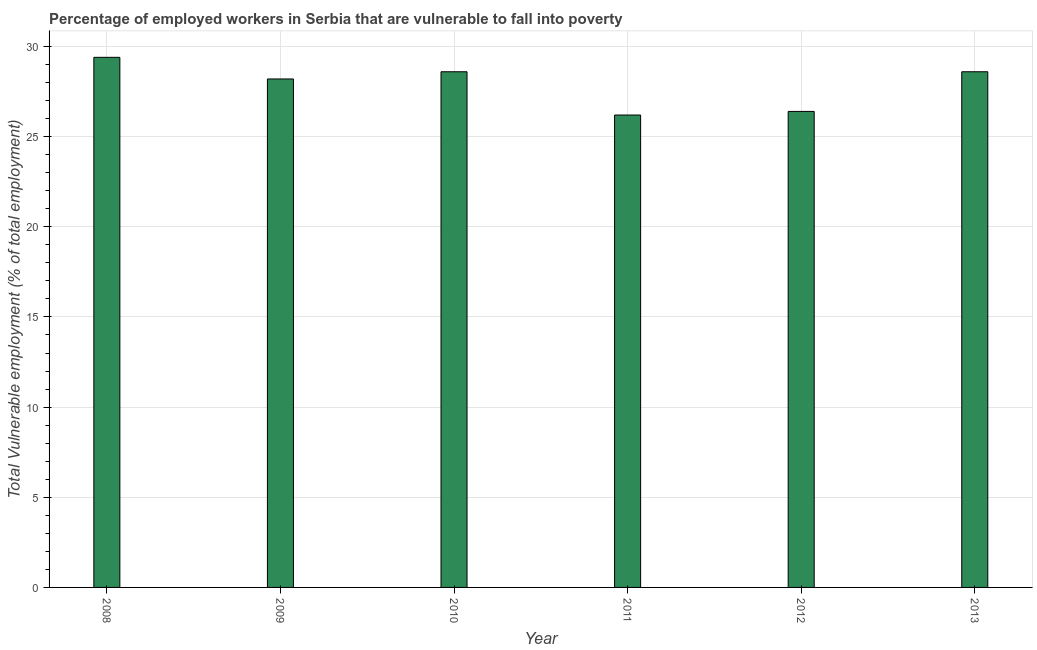Does the graph contain any zero values?
Offer a terse response. No. What is the title of the graph?
Your answer should be compact. Percentage of employed workers in Serbia that are vulnerable to fall into poverty. What is the label or title of the Y-axis?
Offer a terse response. Total Vulnerable employment (% of total employment). What is the total vulnerable employment in 2012?
Make the answer very short. 26.4. Across all years, what is the maximum total vulnerable employment?
Provide a succinct answer. 29.4. Across all years, what is the minimum total vulnerable employment?
Your answer should be very brief. 26.2. In which year was the total vulnerable employment maximum?
Offer a terse response. 2008. What is the sum of the total vulnerable employment?
Ensure brevity in your answer.  167.4. What is the average total vulnerable employment per year?
Keep it short and to the point. 27.9. What is the median total vulnerable employment?
Ensure brevity in your answer.  28.4. In how many years, is the total vulnerable employment greater than 6 %?
Keep it short and to the point. 6. What is the ratio of the total vulnerable employment in 2009 to that in 2012?
Your response must be concise. 1.07. Is the total vulnerable employment in 2011 less than that in 2013?
Your response must be concise. Yes. Is the sum of the total vulnerable employment in 2010 and 2011 greater than the maximum total vulnerable employment across all years?
Keep it short and to the point. Yes. In how many years, is the total vulnerable employment greater than the average total vulnerable employment taken over all years?
Offer a very short reply. 4. Are all the bars in the graph horizontal?
Offer a terse response. No. What is the Total Vulnerable employment (% of total employment) in 2008?
Give a very brief answer. 29.4. What is the Total Vulnerable employment (% of total employment) in 2009?
Give a very brief answer. 28.2. What is the Total Vulnerable employment (% of total employment) of 2010?
Give a very brief answer. 28.6. What is the Total Vulnerable employment (% of total employment) of 2011?
Your answer should be compact. 26.2. What is the Total Vulnerable employment (% of total employment) of 2012?
Offer a very short reply. 26.4. What is the Total Vulnerable employment (% of total employment) in 2013?
Your answer should be compact. 28.6. What is the difference between the Total Vulnerable employment (% of total employment) in 2008 and 2009?
Provide a succinct answer. 1.2. What is the difference between the Total Vulnerable employment (% of total employment) in 2008 and 2010?
Keep it short and to the point. 0.8. What is the difference between the Total Vulnerable employment (% of total employment) in 2008 and 2011?
Keep it short and to the point. 3.2. What is the difference between the Total Vulnerable employment (% of total employment) in 2008 and 2012?
Your answer should be very brief. 3. What is the difference between the Total Vulnerable employment (% of total employment) in 2009 and 2010?
Your answer should be very brief. -0.4. What is the difference between the Total Vulnerable employment (% of total employment) in 2009 and 2011?
Your answer should be very brief. 2. What is the difference between the Total Vulnerable employment (% of total employment) in 2009 and 2012?
Make the answer very short. 1.8. What is the difference between the Total Vulnerable employment (% of total employment) in 2009 and 2013?
Your response must be concise. -0.4. What is the difference between the Total Vulnerable employment (% of total employment) in 2010 and 2011?
Provide a succinct answer. 2.4. What is the difference between the Total Vulnerable employment (% of total employment) in 2010 and 2013?
Provide a succinct answer. 0. What is the difference between the Total Vulnerable employment (% of total employment) in 2012 and 2013?
Keep it short and to the point. -2.2. What is the ratio of the Total Vulnerable employment (% of total employment) in 2008 to that in 2009?
Your answer should be compact. 1.04. What is the ratio of the Total Vulnerable employment (% of total employment) in 2008 to that in 2010?
Keep it short and to the point. 1.03. What is the ratio of the Total Vulnerable employment (% of total employment) in 2008 to that in 2011?
Keep it short and to the point. 1.12. What is the ratio of the Total Vulnerable employment (% of total employment) in 2008 to that in 2012?
Make the answer very short. 1.11. What is the ratio of the Total Vulnerable employment (% of total employment) in 2008 to that in 2013?
Make the answer very short. 1.03. What is the ratio of the Total Vulnerable employment (% of total employment) in 2009 to that in 2010?
Offer a very short reply. 0.99. What is the ratio of the Total Vulnerable employment (% of total employment) in 2009 to that in 2011?
Offer a terse response. 1.08. What is the ratio of the Total Vulnerable employment (% of total employment) in 2009 to that in 2012?
Provide a short and direct response. 1.07. What is the ratio of the Total Vulnerable employment (% of total employment) in 2010 to that in 2011?
Offer a very short reply. 1.09. What is the ratio of the Total Vulnerable employment (% of total employment) in 2010 to that in 2012?
Give a very brief answer. 1.08. What is the ratio of the Total Vulnerable employment (% of total employment) in 2011 to that in 2013?
Keep it short and to the point. 0.92. What is the ratio of the Total Vulnerable employment (% of total employment) in 2012 to that in 2013?
Your answer should be compact. 0.92. 